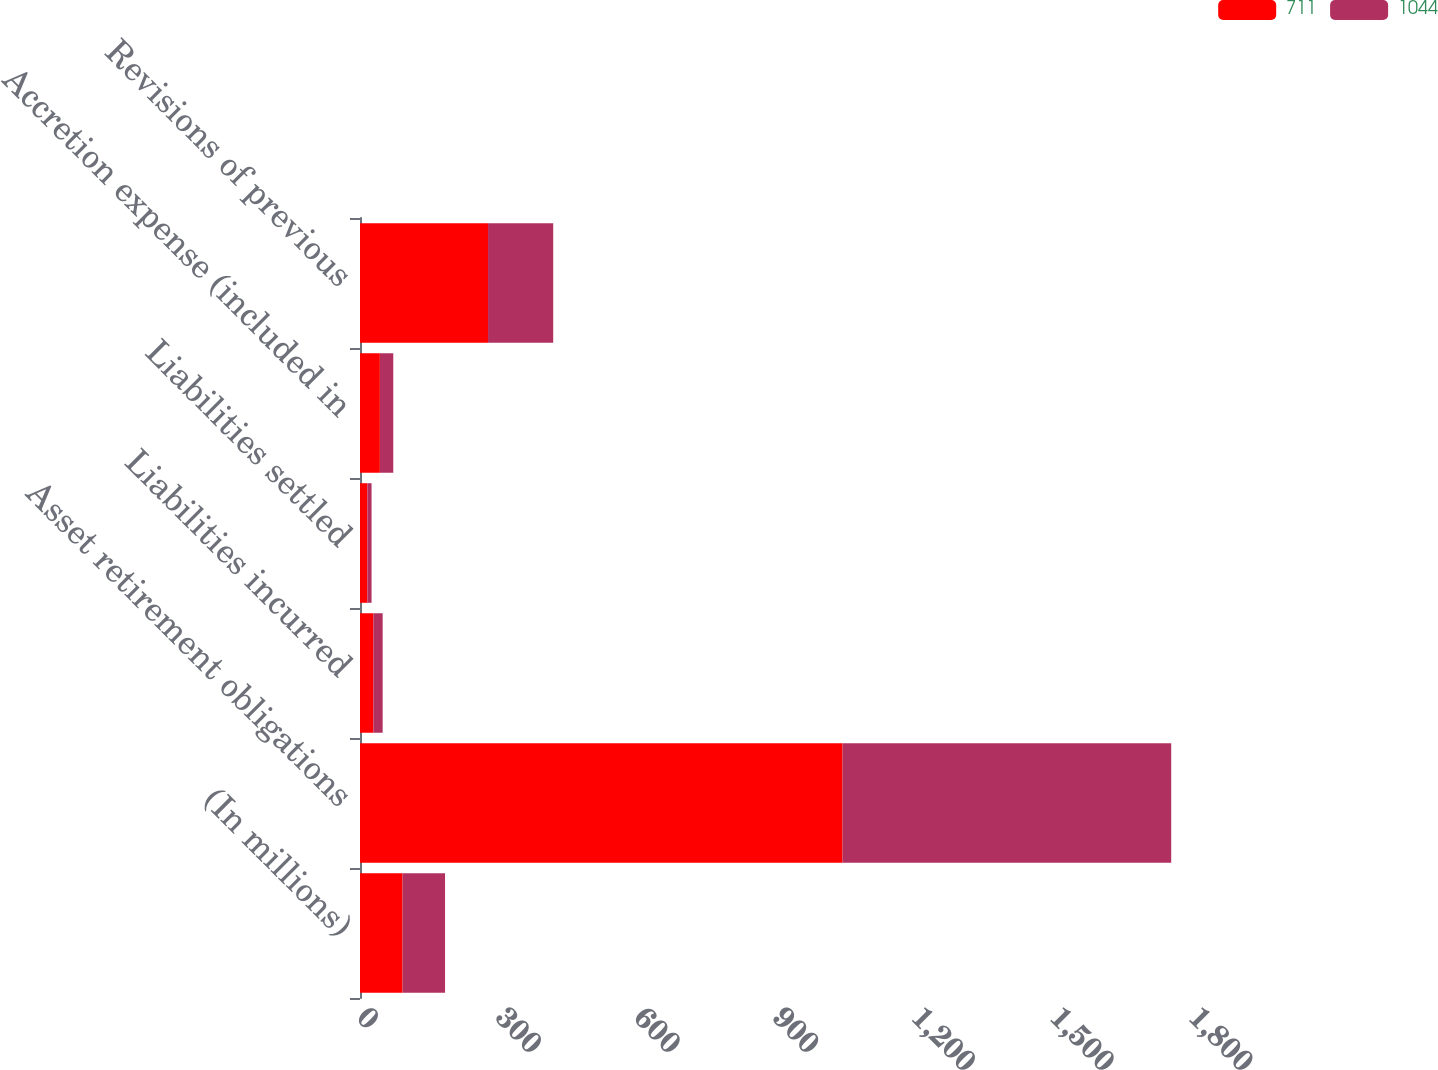Convert chart. <chart><loc_0><loc_0><loc_500><loc_500><stacked_bar_chart><ecel><fcel>(In millions)<fcel>Asset retirement obligations<fcel>Liabilities incurred<fcel>Liabilities settled<fcel>Accretion expense (included in<fcel>Revisions of previous<nl><fcel>711<fcel>92<fcel>1044<fcel>29<fcel>16<fcel>43<fcel>277<nl><fcel>1044<fcel>92<fcel>711<fcel>20<fcel>9<fcel>29<fcel>141<nl></chart> 